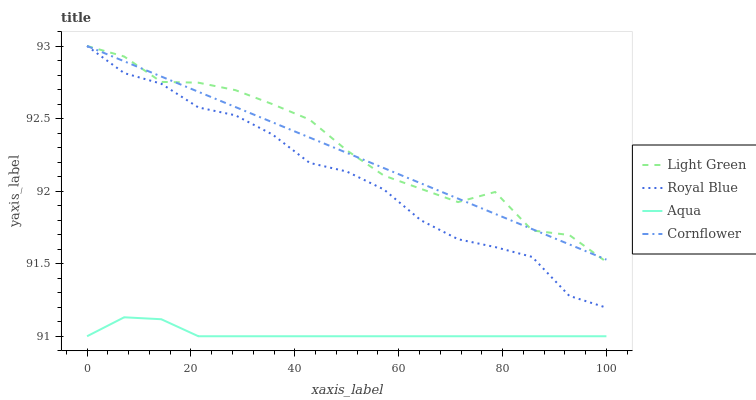Does Aqua have the minimum area under the curve?
Answer yes or no. Yes. Does Light Green have the maximum area under the curve?
Answer yes or no. Yes. Does Light Green have the minimum area under the curve?
Answer yes or no. No. Does Aqua have the maximum area under the curve?
Answer yes or no. No. Is Cornflower the smoothest?
Answer yes or no. Yes. Is Light Green the roughest?
Answer yes or no. Yes. Is Aqua the smoothest?
Answer yes or no. No. Is Aqua the roughest?
Answer yes or no. No. Does Light Green have the lowest value?
Answer yes or no. No. Does Cornflower have the highest value?
Answer yes or no. Yes. Does Aqua have the highest value?
Answer yes or no. No. Is Aqua less than Cornflower?
Answer yes or no. Yes. Is Royal Blue greater than Aqua?
Answer yes or no. Yes. Does Light Green intersect Cornflower?
Answer yes or no. Yes. Is Light Green less than Cornflower?
Answer yes or no. No. Is Light Green greater than Cornflower?
Answer yes or no. No. Does Aqua intersect Cornflower?
Answer yes or no. No. 